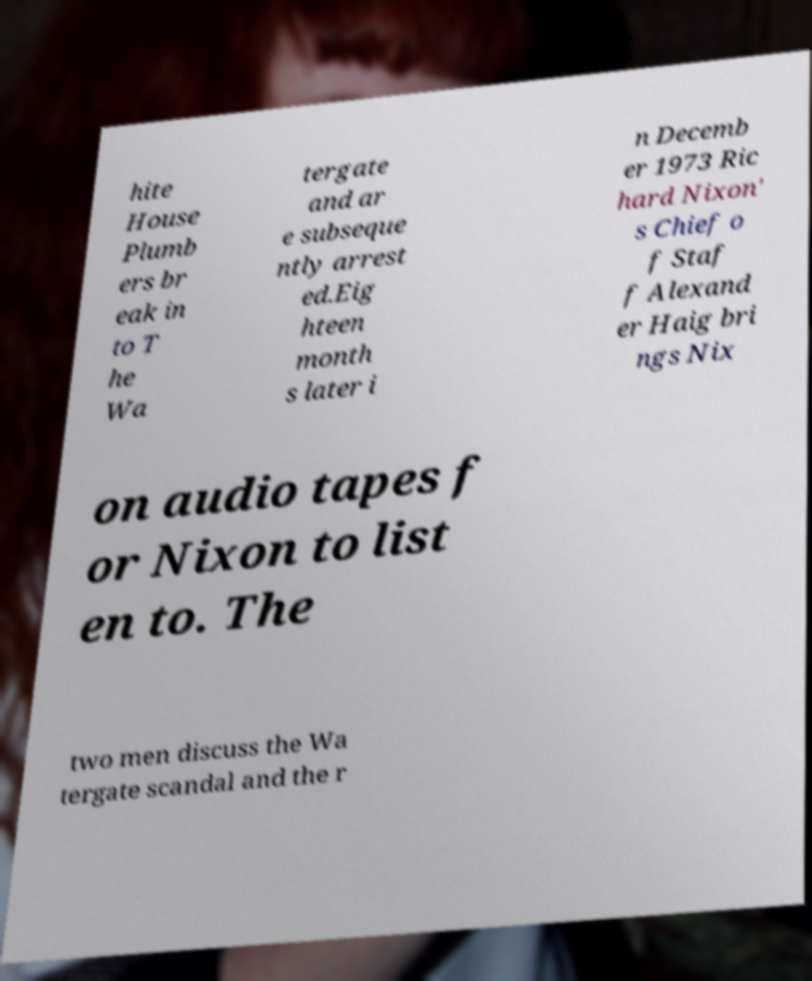Could you assist in decoding the text presented in this image and type it out clearly? hite House Plumb ers br eak in to T he Wa tergate and ar e subseque ntly arrest ed.Eig hteen month s later i n Decemb er 1973 Ric hard Nixon' s Chief o f Staf f Alexand er Haig bri ngs Nix on audio tapes f or Nixon to list en to. The two men discuss the Wa tergate scandal and the r 